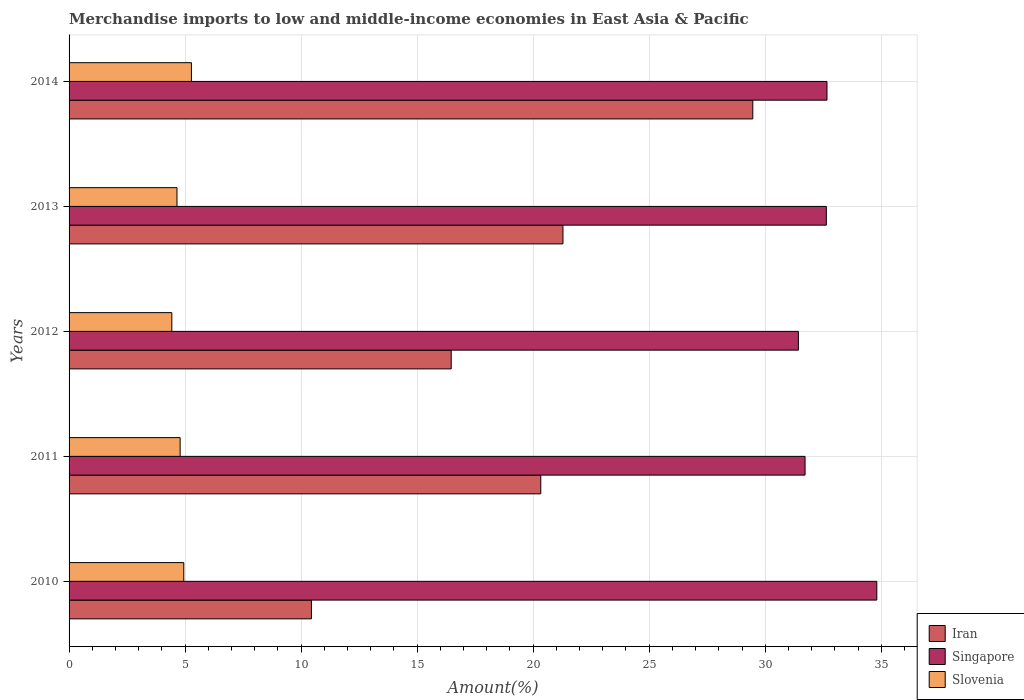How many different coloured bars are there?
Give a very brief answer. 3. How many groups of bars are there?
Ensure brevity in your answer.  5. Are the number of bars on each tick of the Y-axis equal?
Your answer should be compact. Yes. In how many cases, is the number of bars for a given year not equal to the number of legend labels?
Your answer should be compact. 0. What is the percentage of amount earned from merchandise imports in Iran in 2011?
Offer a very short reply. 20.33. Across all years, what is the maximum percentage of amount earned from merchandise imports in Singapore?
Your response must be concise. 34.81. Across all years, what is the minimum percentage of amount earned from merchandise imports in Singapore?
Provide a succinct answer. 31.43. In which year was the percentage of amount earned from merchandise imports in Iran maximum?
Offer a terse response. 2014. In which year was the percentage of amount earned from merchandise imports in Iran minimum?
Make the answer very short. 2010. What is the total percentage of amount earned from merchandise imports in Singapore in the graph?
Your answer should be compact. 163.25. What is the difference between the percentage of amount earned from merchandise imports in Singapore in 2011 and that in 2012?
Provide a succinct answer. 0.29. What is the difference between the percentage of amount earned from merchandise imports in Iran in 2011 and the percentage of amount earned from merchandise imports in Slovenia in 2012?
Provide a short and direct response. 15.9. What is the average percentage of amount earned from merchandise imports in Slovenia per year?
Your response must be concise. 4.82. In the year 2014, what is the difference between the percentage of amount earned from merchandise imports in Iran and percentage of amount earned from merchandise imports in Slovenia?
Give a very brief answer. 24.19. What is the ratio of the percentage of amount earned from merchandise imports in Singapore in 2012 to that in 2014?
Your response must be concise. 0.96. Is the percentage of amount earned from merchandise imports in Singapore in 2010 less than that in 2011?
Provide a succinct answer. No. What is the difference between the highest and the second highest percentage of amount earned from merchandise imports in Slovenia?
Give a very brief answer. 0.33. What is the difference between the highest and the lowest percentage of amount earned from merchandise imports in Slovenia?
Provide a succinct answer. 0.84. What does the 2nd bar from the top in 2013 represents?
Give a very brief answer. Singapore. What does the 3rd bar from the bottom in 2011 represents?
Ensure brevity in your answer.  Slovenia. How many bars are there?
Provide a short and direct response. 15. Are all the bars in the graph horizontal?
Provide a short and direct response. Yes. How many years are there in the graph?
Ensure brevity in your answer.  5. Does the graph contain any zero values?
Offer a very short reply. No. Where does the legend appear in the graph?
Provide a succinct answer. Bottom right. How many legend labels are there?
Give a very brief answer. 3. How are the legend labels stacked?
Ensure brevity in your answer.  Vertical. What is the title of the graph?
Offer a terse response. Merchandise imports to low and middle-income economies in East Asia & Pacific. What is the label or title of the X-axis?
Ensure brevity in your answer.  Amount(%). What is the label or title of the Y-axis?
Offer a terse response. Years. What is the Amount(%) of Iran in 2010?
Give a very brief answer. 10.45. What is the Amount(%) of Singapore in 2010?
Offer a terse response. 34.81. What is the Amount(%) in Slovenia in 2010?
Your answer should be compact. 4.94. What is the Amount(%) in Iran in 2011?
Provide a succinct answer. 20.33. What is the Amount(%) in Singapore in 2011?
Your answer should be very brief. 31.72. What is the Amount(%) in Slovenia in 2011?
Offer a very short reply. 4.79. What is the Amount(%) in Iran in 2012?
Your answer should be very brief. 16.47. What is the Amount(%) in Singapore in 2012?
Give a very brief answer. 31.43. What is the Amount(%) in Slovenia in 2012?
Ensure brevity in your answer.  4.43. What is the Amount(%) of Iran in 2013?
Provide a succinct answer. 21.28. What is the Amount(%) in Singapore in 2013?
Give a very brief answer. 32.63. What is the Amount(%) in Slovenia in 2013?
Make the answer very short. 4.65. What is the Amount(%) in Iran in 2014?
Offer a very short reply. 29.47. What is the Amount(%) in Singapore in 2014?
Give a very brief answer. 32.66. What is the Amount(%) of Slovenia in 2014?
Ensure brevity in your answer.  5.27. Across all years, what is the maximum Amount(%) in Iran?
Offer a very short reply. 29.47. Across all years, what is the maximum Amount(%) of Singapore?
Keep it short and to the point. 34.81. Across all years, what is the maximum Amount(%) in Slovenia?
Offer a very short reply. 5.27. Across all years, what is the minimum Amount(%) of Iran?
Provide a succinct answer. 10.45. Across all years, what is the minimum Amount(%) in Singapore?
Provide a short and direct response. 31.43. Across all years, what is the minimum Amount(%) of Slovenia?
Make the answer very short. 4.43. What is the total Amount(%) of Iran in the graph?
Provide a succinct answer. 97.99. What is the total Amount(%) of Singapore in the graph?
Your response must be concise. 163.25. What is the total Amount(%) in Slovenia in the graph?
Give a very brief answer. 24.08. What is the difference between the Amount(%) of Iran in 2010 and that in 2011?
Your response must be concise. -9.88. What is the difference between the Amount(%) of Singapore in 2010 and that in 2011?
Offer a very short reply. 3.09. What is the difference between the Amount(%) in Slovenia in 2010 and that in 2011?
Give a very brief answer. 0.16. What is the difference between the Amount(%) in Iran in 2010 and that in 2012?
Your answer should be very brief. -6.02. What is the difference between the Amount(%) in Singapore in 2010 and that in 2012?
Offer a very short reply. 3.38. What is the difference between the Amount(%) of Slovenia in 2010 and that in 2012?
Keep it short and to the point. 0.51. What is the difference between the Amount(%) of Iran in 2010 and that in 2013?
Provide a succinct answer. -10.84. What is the difference between the Amount(%) in Singapore in 2010 and that in 2013?
Your answer should be compact. 2.17. What is the difference between the Amount(%) of Slovenia in 2010 and that in 2013?
Ensure brevity in your answer.  0.29. What is the difference between the Amount(%) of Iran in 2010 and that in 2014?
Provide a short and direct response. -19.02. What is the difference between the Amount(%) of Singapore in 2010 and that in 2014?
Your response must be concise. 2.15. What is the difference between the Amount(%) in Slovenia in 2010 and that in 2014?
Offer a terse response. -0.33. What is the difference between the Amount(%) in Iran in 2011 and that in 2012?
Give a very brief answer. 3.86. What is the difference between the Amount(%) of Singapore in 2011 and that in 2012?
Provide a succinct answer. 0.29. What is the difference between the Amount(%) in Slovenia in 2011 and that in 2012?
Ensure brevity in your answer.  0.36. What is the difference between the Amount(%) in Iran in 2011 and that in 2013?
Offer a terse response. -0.96. What is the difference between the Amount(%) in Singapore in 2011 and that in 2013?
Give a very brief answer. -0.92. What is the difference between the Amount(%) of Slovenia in 2011 and that in 2013?
Your answer should be very brief. 0.14. What is the difference between the Amount(%) of Iran in 2011 and that in 2014?
Keep it short and to the point. -9.14. What is the difference between the Amount(%) in Singapore in 2011 and that in 2014?
Offer a very short reply. -0.94. What is the difference between the Amount(%) of Slovenia in 2011 and that in 2014?
Offer a terse response. -0.49. What is the difference between the Amount(%) of Iran in 2012 and that in 2013?
Give a very brief answer. -4.82. What is the difference between the Amount(%) of Singapore in 2012 and that in 2013?
Give a very brief answer. -1.2. What is the difference between the Amount(%) in Slovenia in 2012 and that in 2013?
Your answer should be compact. -0.22. What is the difference between the Amount(%) of Iran in 2012 and that in 2014?
Your answer should be very brief. -13. What is the difference between the Amount(%) of Singapore in 2012 and that in 2014?
Give a very brief answer. -1.23. What is the difference between the Amount(%) of Slovenia in 2012 and that in 2014?
Your response must be concise. -0.84. What is the difference between the Amount(%) of Iran in 2013 and that in 2014?
Make the answer very short. -8.18. What is the difference between the Amount(%) in Singapore in 2013 and that in 2014?
Make the answer very short. -0.03. What is the difference between the Amount(%) in Slovenia in 2013 and that in 2014?
Offer a terse response. -0.62. What is the difference between the Amount(%) in Iran in 2010 and the Amount(%) in Singapore in 2011?
Make the answer very short. -21.27. What is the difference between the Amount(%) in Iran in 2010 and the Amount(%) in Slovenia in 2011?
Provide a succinct answer. 5.66. What is the difference between the Amount(%) of Singapore in 2010 and the Amount(%) of Slovenia in 2011?
Your response must be concise. 30.02. What is the difference between the Amount(%) of Iran in 2010 and the Amount(%) of Singapore in 2012?
Offer a terse response. -20.98. What is the difference between the Amount(%) of Iran in 2010 and the Amount(%) of Slovenia in 2012?
Your answer should be very brief. 6.02. What is the difference between the Amount(%) of Singapore in 2010 and the Amount(%) of Slovenia in 2012?
Provide a short and direct response. 30.38. What is the difference between the Amount(%) in Iran in 2010 and the Amount(%) in Singapore in 2013?
Your answer should be compact. -22.19. What is the difference between the Amount(%) of Iran in 2010 and the Amount(%) of Slovenia in 2013?
Ensure brevity in your answer.  5.79. What is the difference between the Amount(%) of Singapore in 2010 and the Amount(%) of Slovenia in 2013?
Offer a very short reply. 30.16. What is the difference between the Amount(%) of Iran in 2010 and the Amount(%) of Singapore in 2014?
Offer a terse response. -22.22. What is the difference between the Amount(%) of Iran in 2010 and the Amount(%) of Slovenia in 2014?
Provide a short and direct response. 5.17. What is the difference between the Amount(%) of Singapore in 2010 and the Amount(%) of Slovenia in 2014?
Ensure brevity in your answer.  29.54. What is the difference between the Amount(%) in Iran in 2011 and the Amount(%) in Singapore in 2012?
Make the answer very short. -11.1. What is the difference between the Amount(%) in Iran in 2011 and the Amount(%) in Slovenia in 2012?
Keep it short and to the point. 15.9. What is the difference between the Amount(%) in Singapore in 2011 and the Amount(%) in Slovenia in 2012?
Give a very brief answer. 27.29. What is the difference between the Amount(%) of Iran in 2011 and the Amount(%) of Singapore in 2013?
Provide a short and direct response. -12.31. What is the difference between the Amount(%) of Iran in 2011 and the Amount(%) of Slovenia in 2013?
Your response must be concise. 15.68. What is the difference between the Amount(%) in Singapore in 2011 and the Amount(%) in Slovenia in 2013?
Provide a succinct answer. 27.07. What is the difference between the Amount(%) in Iran in 2011 and the Amount(%) in Singapore in 2014?
Offer a very short reply. -12.33. What is the difference between the Amount(%) of Iran in 2011 and the Amount(%) of Slovenia in 2014?
Provide a short and direct response. 15.06. What is the difference between the Amount(%) in Singapore in 2011 and the Amount(%) in Slovenia in 2014?
Provide a short and direct response. 26.45. What is the difference between the Amount(%) in Iran in 2012 and the Amount(%) in Singapore in 2013?
Offer a terse response. -16.17. What is the difference between the Amount(%) of Iran in 2012 and the Amount(%) of Slovenia in 2013?
Ensure brevity in your answer.  11.82. What is the difference between the Amount(%) of Singapore in 2012 and the Amount(%) of Slovenia in 2013?
Your answer should be compact. 26.78. What is the difference between the Amount(%) in Iran in 2012 and the Amount(%) in Singapore in 2014?
Offer a very short reply. -16.19. What is the difference between the Amount(%) in Iran in 2012 and the Amount(%) in Slovenia in 2014?
Your answer should be very brief. 11.2. What is the difference between the Amount(%) in Singapore in 2012 and the Amount(%) in Slovenia in 2014?
Offer a very short reply. 26.16. What is the difference between the Amount(%) in Iran in 2013 and the Amount(%) in Singapore in 2014?
Your answer should be compact. -11.38. What is the difference between the Amount(%) of Iran in 2013 and the Amount(%) of Slovenia in 2014?
Ensure brevity in your answer.  16.01. What is the difference between the Amount(%) of Singapore in 2013 and the Amount(%) of Slovenia in 2014?
Your response must be concise. 27.36. What is the average Amount(%) in Iran per year?
Your response must be concise. 19.6. What is the average Amount(%) of Singapore per year?
Give a very brief answer. 32.65. What is the average Amount(%) of Slovenia per year?
Your answer should be compact. 4.82. In the year 2010, what is the difference between the Amount(%) of Iran and Amount(%) of Singapore?
Provide a short and direct response. -24.36. In the year 2010, what is the difference between the Amount(%) of Iran and Amount(%) of Slovenia?
Give a very brief answer. 5.5. In the year 2010, what is the difference between the Amount(%) of Singapore and Amount(%) of Slovenia?
Give a very brief answer. 29.87. In the year 2011, what is the difference between the Amount(%) in Iran and Amount(%) in Singapore?
Offer a very short reply. -11.39. In the year 2011, what is the difference between the Amount(%) of Iran and Amount(%) of Slovenia?
Your answer should be very brief. 15.54. In the year 2011, what is the difference between the Amount(%) in Singapore and Amount(%) in Slovenia?
Make the answer very short. 26.93. In the year 2012, what is the difference between the Amount(%) of Iran and Amount(%) of Singapore?
Give a very brief answer. -14.96. In the year 2012, what is the difference between the Amount(%) of Iran and Amount(%) of Slovenia?
Provide a succinct answer. 12.04. In the year 2012, what is the difference between the Amount(%) in Singapore and Amount(%) in Slovenia?
Offer a terse response. 27. In the year 2013, what is the difference between the Amount(%) in Iran and Amount(%) in Singapore?
Your response must be concise. -11.35. In the year 2013, what is the difference between the Amount(%) of Iran and Amount(%) of Slovenia?
Keep it short and to the point. 16.63. In the year 2013, what is the difference between the Amount(%) of Singapore and Amount(%) of Slovenia?
Provide a succinct answer. 27.98. In the year 2014, what is the difference between the Amount(%) of Iran and Amount(%) of Singapore?
Offer a terse response. -3.2. In the year 2014, what is the difference between the Amount(%) in Iran and Amount(%) in Slovenia?
Provide a succinct answer. 24.19. In the year 2014, what is the difference between the Amount(%) of Singapore and Amount(%) of Slovenia?
Give a very brief answer. 27.39. What is the ratio of the Amount(%) in Iran in 2010 to that in 2011?
Your answer should be compact. 0.51. What is the ratio of the Amount(%) in Singapore in 2010 to that in 2011?
Keep it short and to the point. 1.1. What is the ratio of the Amount(%) of Slovenia in 2010 to that in 2011?
Ensure brevity in your answer.  1.03. What is the ratio of the Amount(%) of Iran in 2010 to that in 2012?
Provide a short and direct response. 0.63. What is the ratio of the Amount(%) in Singapore in 2010 to that in 2012?
Offer a terse response. 1.11. What is the ratio of the Amount(%) in Slovenia in 2010 to that in 2012?
Offer a terse response. 1.12. What is the ratio of the Amount(%) of Iran in 2010 to that in 2013?
Your answer should be very brief. 0.49. What is the ratio of the Amount(%) of Singapore in 2010 to that in 2013?
Provide a short and direct response. 1.07. What is the ratio of the Amount(%) of Slovenia in 2010 to that in 2013?
Your answer should be compact. 1.06. What is the ratio of the Amount(%) of Iran in 2010 to that in 2014?
Provide a short and direct response. 0.35. What is the ratio of the Amount(%) of Singapore in 2010 to that in 2014?
Make the answer very short. 1.07. What is the ratio of the Amount(%) of Slovenia in 2010 to that in 2014?
Your response must be concise. 0.94. What is the ratio of the Amount(%) in Iran in 2011 to that in 2012?
Keep it short and to the point. 1.23. What is the ratio of the Amount(%) in Singapore in 2011 to that in 2012?
Offer a very short reply. 1.01. What is the ratio of the Amount(%) of Slovenia in 2011 to that in 2012?
Your answer should be very brief. 1.08. What is the ratio of the Amount(%) in Iran in 2011 to that in 2013?
Keep it short and to the point. 0.96. What is the ratio of the Amount(%) of Singapore in 2011 to that in 2013?
Ensure brevity in your answer.  0.97. What is the ratio of the Amount(%) of Slovenia in 2011 to that in 2013?
Provide a succinct answer. 1.03. What is the ratio of the Amount(%) in Iran in 2011 to that in 2014?
Your answer should be very brief. 0.69. What is the ratio of the Amount(%) of Singapore in 2011 to that in 2014?
Keep it short and to the point. 0.97. What is the ratio of the Amount(%) in Slovenia in 2011 to that in 2014?
Make the answer very short. 0.91. What is the ratio of the Amount(%) of Iran in 2012 to that in 2013?
Keep it short and to the point. 0.77. What is the ratio of the Amount(%) of Singapore in 2012 to that in 2013?
Make the answer very short. 0.96. What is the ratio of the Amount(%) of Slovenia in 2012 to that in 2013?
Your answer should be very brief. 0.95. What is the ratio of the Amount(%) of Iran in 2012 to that in 2014?
Your answer should be compact. 0.56. What is the ratio of the Amount(%) in Singapore in 2012 to that in 2014?
Ensure brevity in your answer.  0.96. What is the ratio of the Amount(%) in Slovenia in 2012 to that in 2014?
Keep it short and to the point. 0.84. What is the ratio of the Amount(%) in Iran in 2013 to that in 2014?
Provide a succinct answer. 0.72. What is the ratio of the Amount(%) of Singapore in 2013 to that in 2014?
Your answer should be compact. 1. What is the ratio of the Amount(%) in Slovenia in 2013 to that in 2014?
Provide a short and direct response. 0.88. What is the difference between the highest and the second highest Amount(%) of Iran?
Give a very brief answer. 8.18. What is the difference between the highest and the second highest Amount(%) of Singapore?
Give a very brief answer. 2.15. What is the difference between the highest and the second highest Amount(%) of Slovenia?
Make the answer very short. 0.33. What is the difference between the highest and the lowest Amount(%) of Iran?
Make the answer very short. 19.02. What is the difference between the highest and the lowest Amount(%) in Singapore?
Provide a succinct answer. 3.38. What is the difference between the highest and the lowest Amount(%) in Slovenia?
Offer a terse response. 0.84. 